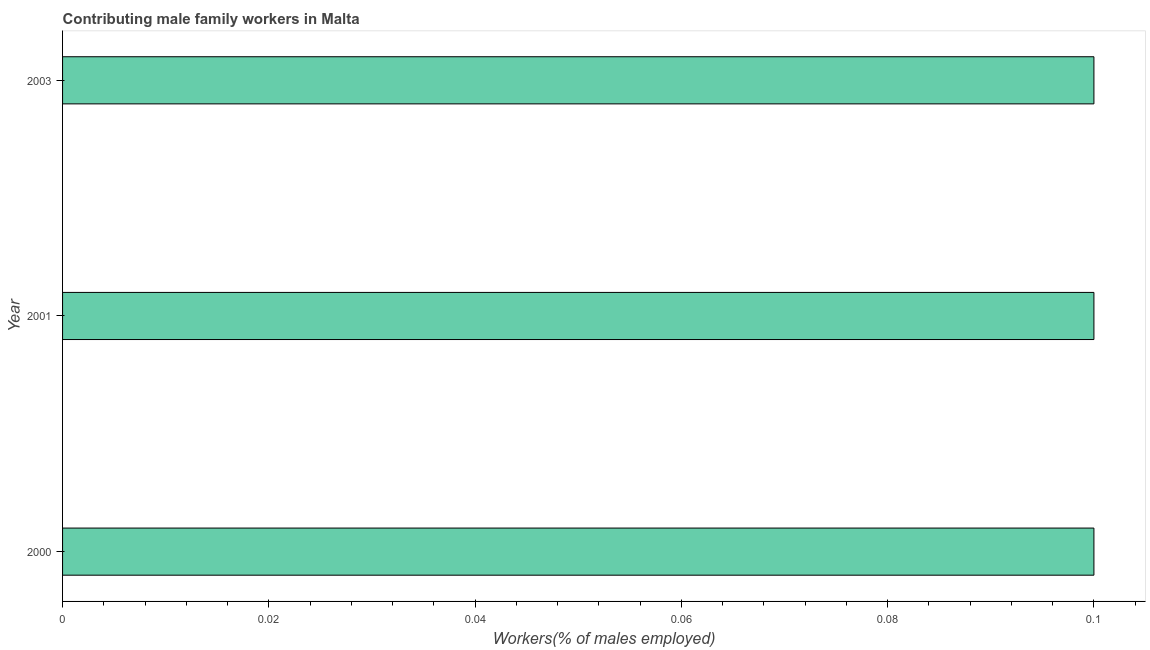What is the title of the graph?
Offer a terse response. Contributing male family workers in Malta. What is the label or title of the X-axis?
Offer a terse response. Workers(% of males employed). What is the contributing male family workers in 2000?
Your answer should be very brief. 0.1. Across all years, what is the maximum contributing male family workers?
Ensure brevity in your answer.  0.1. Across all years, what is the minimum contributing male family workers?
Your response must be concise. 0.1. In which year was the contributing male family workers minimum?
Make the answer very short. 2000. What is the sum of the contributing male family workers?
Your answer should be compact. 0.3. What is the difference between the contributing male family workers in 2000 and 2001?
Provide a short and direct response. 0. What is the average contributing male family workers per year?
Give a very brief answer. 0.1. What is the median contributing male family workers?
Ensure brevity in your answer.  0.1. Do a majority of the years between 2000 and 2001 (inclusive) have contributing male family workers greater than 0.056 %?
Offer a very short reply. Yes. Is the difference between the contributing male family workers in 2000 and 2001 greater than the difference between any two years?
Your answer should be compact. Yes. What is the difference between the highest and the second highest contributing male family workers?
Your response must be concise. 0. What is the difference between the highest and the lowest contributing male family workers?
Keep it short and to the point. 0. How many bars are there?
Give a very brief answer. 3. How many years are there in the graph?
Provide a short and direct response. 3. Are the values on the major ticks of X-axis written in scientific E-notation?
Provide a succinct answer. No. What is the Workers(% of males employed) of 2000?
Your answer should be very brief. 0.1. What is the Workers(% of males employed) of 2001?
Make the answer very short. 0.1. What is the Workers(% of males employed) in 2003?
Make the answer very short. 0.1. What is the difference between the Workers(% of males employed) in 2000 and 2001?
Ensure brevity in your answer.  0. What is the difference between the Workers(% of males employed) in 2000 and 2003?
Give a very brief answer. 0. What is the difference between the Workers(% of males employed) in 2001 and 2003?
Provide a succinct answer. 0. What is the ratio of the Workers(% of males employed) in 2001 to that in 2003?
Offer a terse response. 1. 